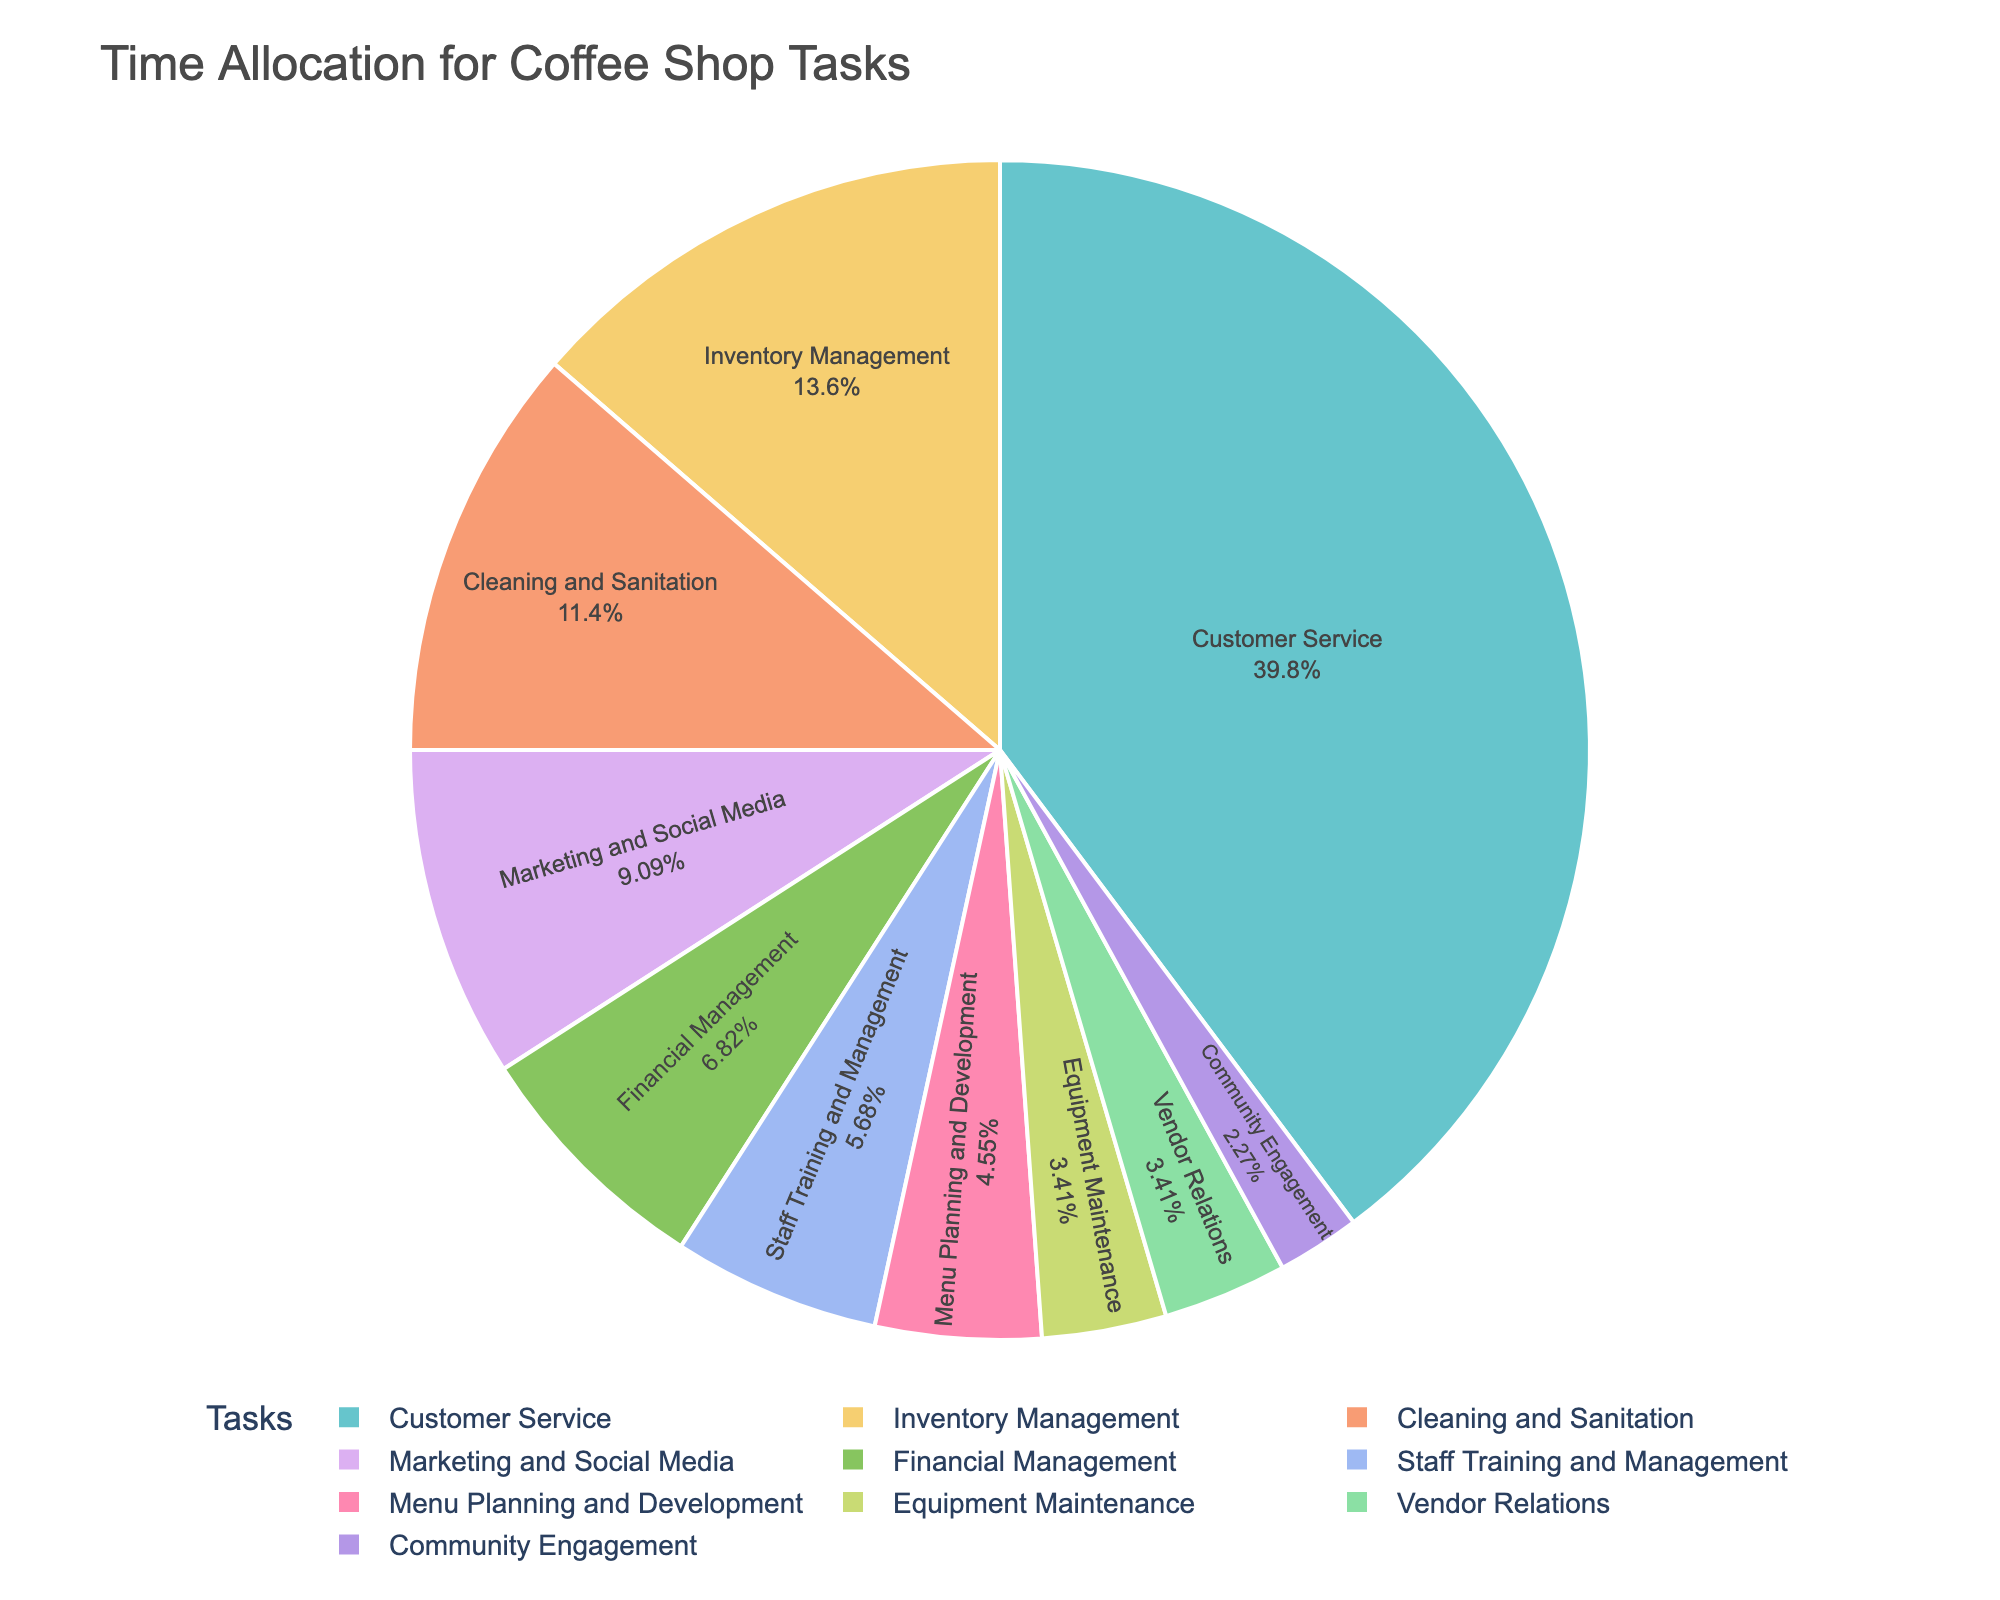What task takes up the most time per week? By looking at the pie chart, we can see which section has the largest area. Customer Service occupies the most significant portion of the pie chart.
Answer: Customer Service What percentage of the total time is spent on Marketing and Social Media? Upon inspecting the pie chart, find the section labeled "Marketing and Social Media" and check its percentage. It represents a specific portion of the total time.
Answer: 8% How much more time is spent on Customer Service than on Inventory Management? From the chart, the hours per week for Customer Service is 35, and for Inventory Management, it is 12. Subtract the hours for Inventory Management from the hours for Customer Service. 35 - 12 = 23
Answer: 23 hours Which task is allocated the least amount of time per week? By observing the smallest section of the pie chart, we can identify the segment representing the least amount of time spent. Community Engagement has the smallest portion.
Answer: Community Engagement What is the combined percentage of time spent on Financial Management and Cleaning and Sanitation? Determine the percentage for each of these tasks from the pie chart and add them together. Financial Management is 6%, and Cleaning and Sanitation is 10%. So, 6% + 10% = 16%
Answer: 16% How does the time spent on Cleaning and Sanitation compare to that spent on Equipment Maintenance? Check the portions of the pie chart for Cleaning and Sanitation and Equipment Maintenance. Cleaning and Sanitation is larger, confirming more time spent on it.
Answer: More time on Cleaning and Sanitation Is the time spent on Equipment Maintenance and Vendor Relations equal? Looking at the pie chart, both Equipment Maintenance and Vendor Relations have segments representing equal amounts of time. Each has 3 hours allocated per week.
Answer: Yes, they are equal What is the total time spent on Staff Training and Management, and Menu Planning and Development combined? Find the hours per week for each task in the pie chart. Staff Training and Management is 5 hours, and Menu Planning and Development is 4 hours. Add them together: 5 + 4 = 9.
Answer: 9 hours Which portion of the pie chart is represented with pastel colors, and which task does it indicate? Identify the sections with different colors and find the task labeled in pastel colors. Each task has a unique color associated with it in the custom palette.
Answer: Tasks are represented in pastel colors, referring to each segment manually How do the hours spent on Marketing and Social Media compare to the hours spent on Financial Management? By examining the chart, Marketing and Social Media has 8 hours, while Financial Management has 6 hours allocated per week. Therefore, Marketing and Social Media has more hours compared to Financial Management.
Answer: More hours on Marketing and Social Media 